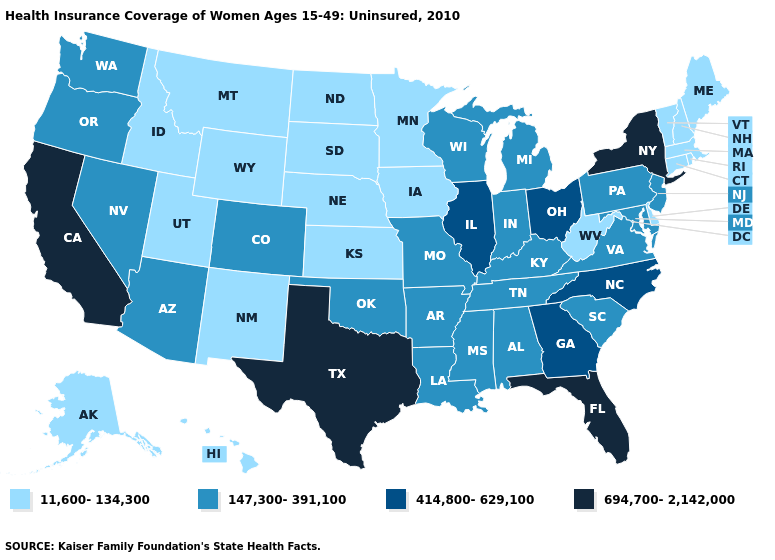Does Florida have the highest value in the South?
Short answer required. Yes. What is the value of Hawaii?
Answer briefly. 11,600-134,300. Does Alabama have the highest value in the South?
Short answer required. No. Does Illinois have a lower value than South Carolina?
Be succinct. No. Does Maine have a lower value than Illinois?
Answer briefly. Yes. Does Tennessee have the lowest value in the South?
Quick response, please. No. Name the states that have a value in the range 11,600-134,300?
Quick response, please. Alaska, Connecticut, Delaware, Hawaii, Idaho, Iowa, Kansas, Maine, Massachusetts, Minnesota, Montana, Nebraska, New Hampshire, New Mexico, North Dakota, Rhode Island, South Dakota, Utah, Vermont, West Virginia, Wyoming. Name the states that have a value in the range 147,300-391,100?
Quick response, please. Alabama, Arizona, Arkansas, Colorado, Indiana, Kentucky, Louisiana, Maryland, Michigan, Mississippi, Missouri, Nevada, New Jersey, Oklahoma, Oregon, Pennsylvania, South Carolina, Tennessee, Virginia, Washington, Wisconsin. Which states have the lowest value in the MidWest?
Keep it brief. Iowa, Kansas, Minnesota, Nebraska, North Dakota, South Dakota. Name the states that have a value in the range 147,300-391,100?
Quick response, please. Alabama, Arizona, Arkansas, Colorado, Indiana, Kentucky, Louisiana, Maryland, Michigan, Mississippi, Missouri, Nevada, New Jersey, Oklahoma, Oregon, Pennsylvania, South Carolina, Tennessee, Virginia, Washington, Wisconsin. What is the highest value in the USA?
Short answer required. 694,700-2,142,000. Does Missouri have a lower value than Massachusetts?
Answer briefly. No. Which states have the lowest value in the South?
Short answer required. Delaware, West Virginia. Does Texas have the highest value in the USA?
Short answer required. Yes. Does the first symbol in the legend represent the smallest category?
Short answer required. Yes. 